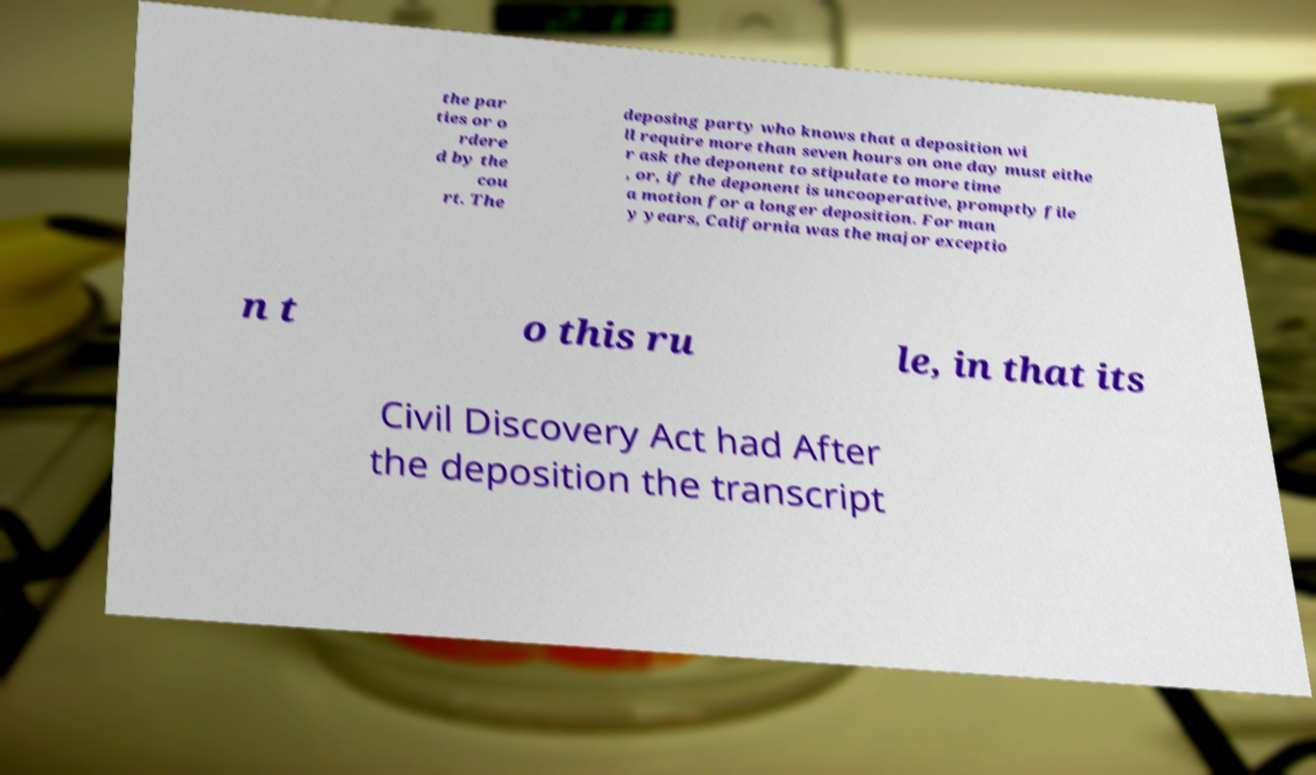Could you extract and type out the text from this image? the par ties or o rdere d by the cou rt. The deposing party who knows that a deposition wi ll require more than seven hours on one day must eithe r ask the deponent to stipulate to more time , or, if the deponent is uncooperative, promptly file a motion for a longer deposition. For man y years, California was the major exceptio n t o this ru le, in that its Civil Discovery Act had After the deposition the transcript 